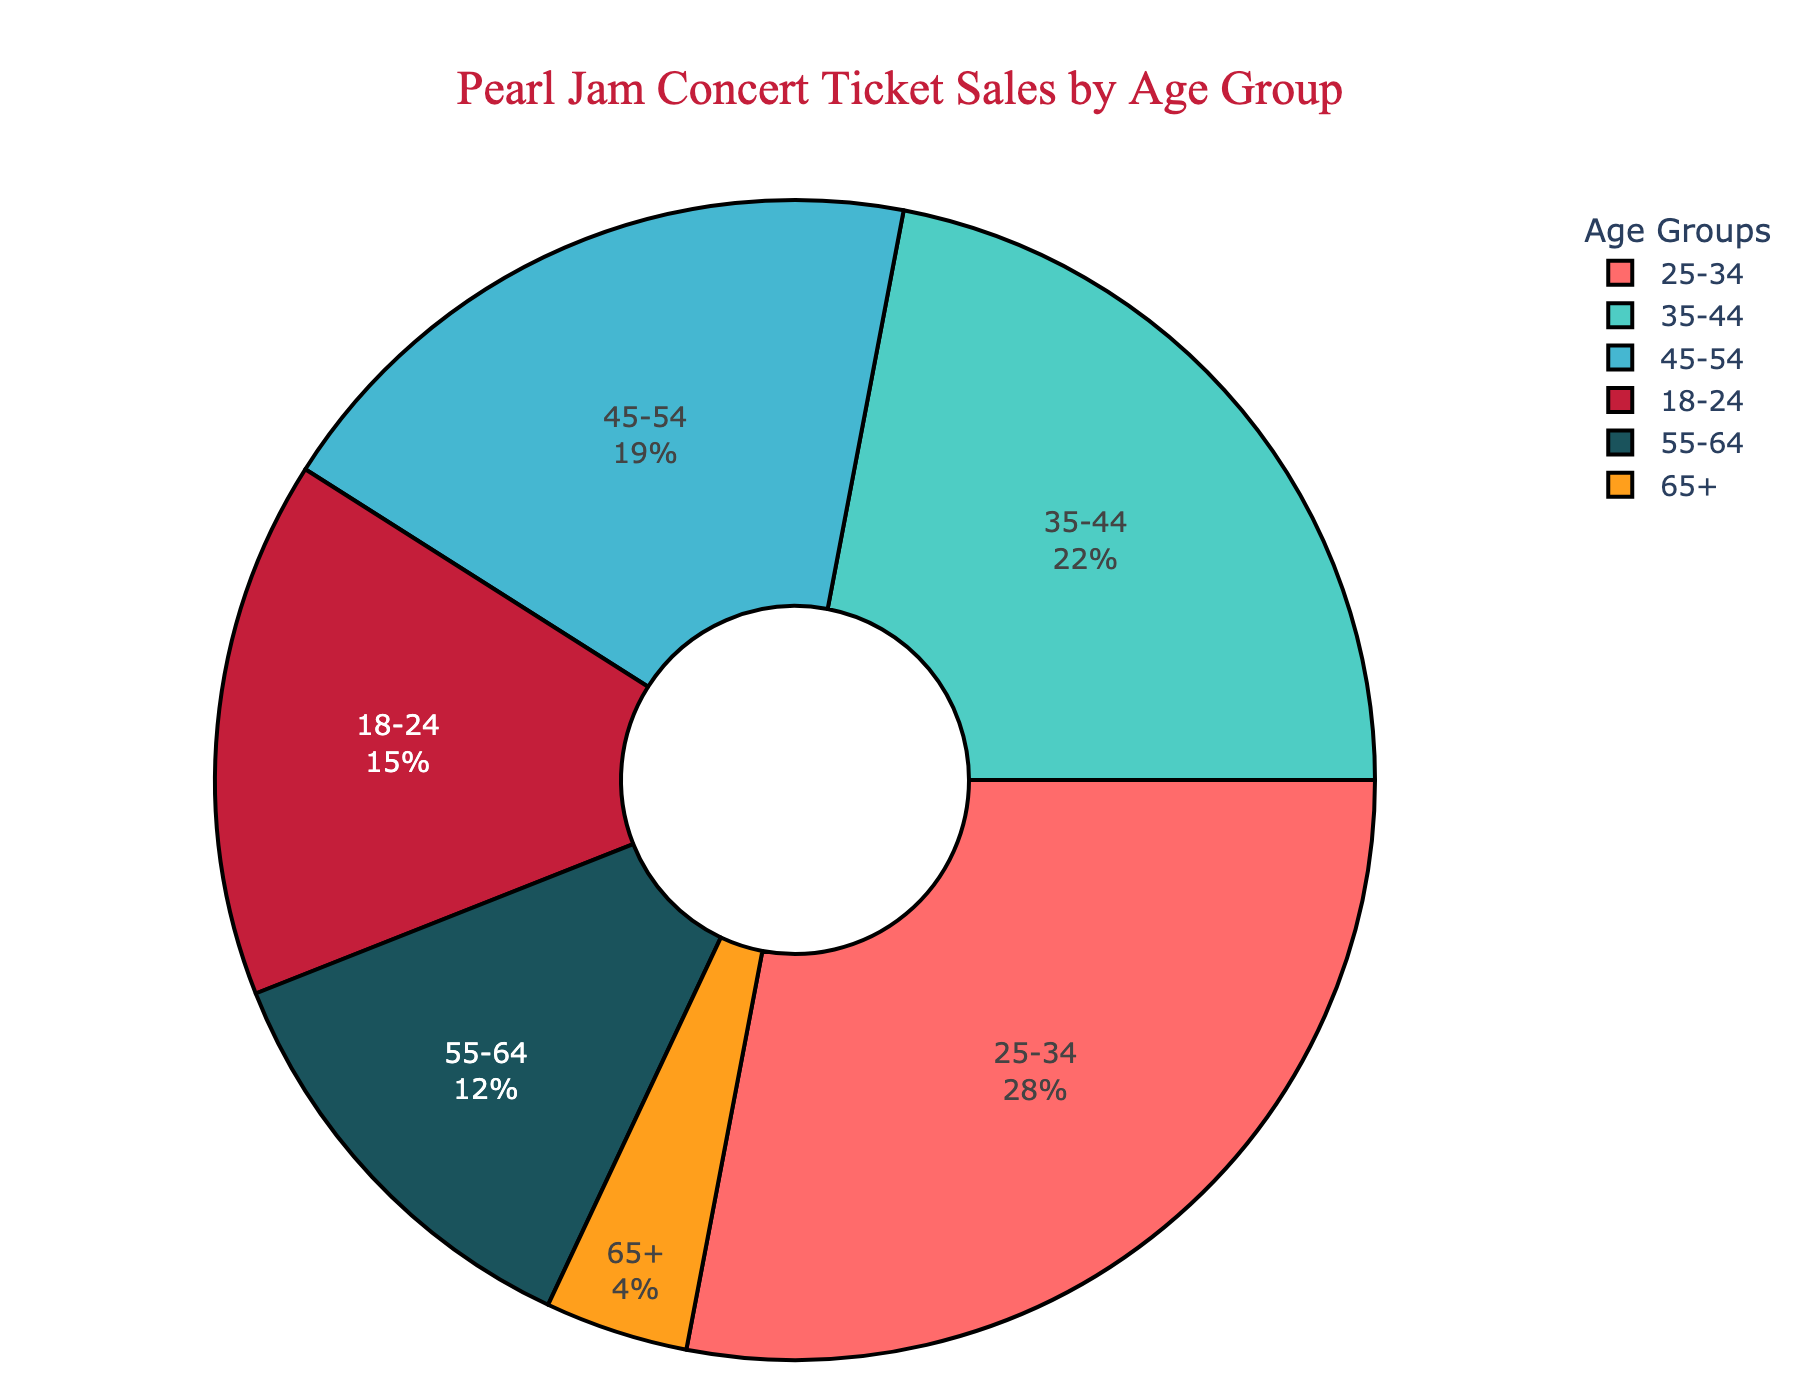What age group has the highest percentage of concert ticket sales? The figure shows the percentage of concert ticket sales for each age group. The age group with the highest percentage is identified as 25-34, which has 28%.
Answer: 25-34 Which age group has the smallest portion of sales? By looking at the pie chart, we observe that the age group with the smallest slice is 65+, which is represented by a 4% portion.
Answer: 65+ What is the combined percentage of ticket sales for the age groups 35-44 and 45-54? Adding the percentages for the age groups 35-44 and 45-54, which are 22% and 19% respectively, we get a total of 41%.
Answer: 41% How much greater is the percentage of sales for the age group 25-34 compared to the age group 18-24? The percentage of sales for 25-34 is 28% and for 18-24 is 15%. Subtracting these values, 28% - 15% gives us 13%.
Answer: 13% Do the combined ticket sales for age groups 18-24 and 55-64 surpass those of the 35-44 group? Adding the percentages for age groups 18-24 and 55-64, we get 15% + 12% = 27%. The 35-44 age group has 22%, which is less than 27%.
Answer: Yes Which color corresponds to the age group 45-54? The pie chart uses specific colors for each age group. By locating the slice and its corresponding legend entry, we see that 45-54 is represented by a shade of blue.
Answer: Blue Is the percentage for the age group 55-64 more than half that of the age group 25-34? The percentage for 55-64 is 12% and for 25-34 is 28%. Half of 28% is 14%, and 12% is less than 14%, so 55-64 is not more than half of 25-34.
Answer: No Which two age groups combined account for over 40% of the ticket sales? Adding the percentages of different combinations, we find that the combination of 25-34 (28%) and 35-44 (22%) gives 50%, which is over 40%.
Answer: 25-34 and 35-44 